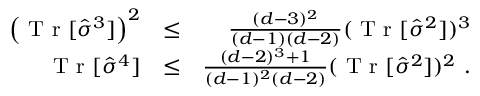<formula> <loc_0><loc_0><loc_500><loc_500>\begin{array} { r l r } { \left ( T r [ \hat { \sigma } ^ { 3 } ] \right ) ^ { 2 } } & { \leq } & { \frac { ( d - 3 ) ^ { 2 } } { ( d - 1 ) ( d - 2 ) } ( T r [ \hat { \sigma } ^ { 2 } ] ) ^ { 3 } } \\ { T r [ \hat { \sigma } ^ { 4 } ] } & { \leq } & { \frac { ( d - 2 ) ^ { 3 } + 1 } { ( d - 1 ) ^ { 2 } ( d - 2 ) } ( T r [ \hat { \sigma } ^ { 2 } ] ) ^ { 2 } \ . } \end{array}</formula> 